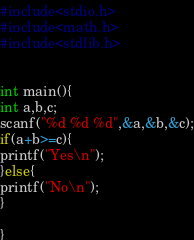Convert code to text. <code><loc_0><loc_0><loc_500><loc_500><_C_>#include<stdio.h>
#include<math.h>
#include<stdlib.h>


int main(){
int a,b,c;
scanf("%d %d %d",&a,&b,&c);
if(a+b>=c){
printf("Yes\n");
}else{
printf("No\n");
}

}

</code> 